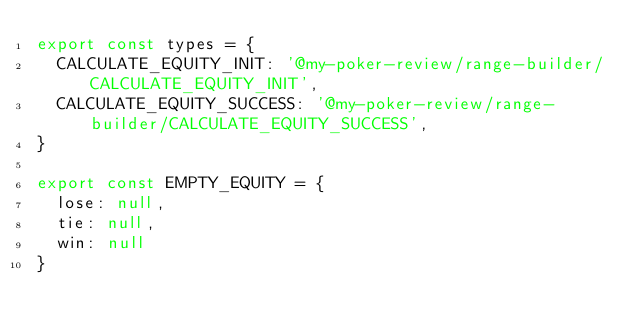Convert code to text. <code><loc_0><loc_0><loc_500><loc_500><_JavaScript_>export const types = {
  CALCULATE_EQUITY_INIT: '@my-poker-review/range-builder/CALCULATE_EQUITY_INIT',
  CALCULATE_EQUITY_SUCCESS: '@my-poker-review/range-builder/CALCULATE_EQUITY_SUCCESS',
}

export const EMPTY_EQUITY = {
  lose: null,
  tie: null,
  win: null
}</code> 